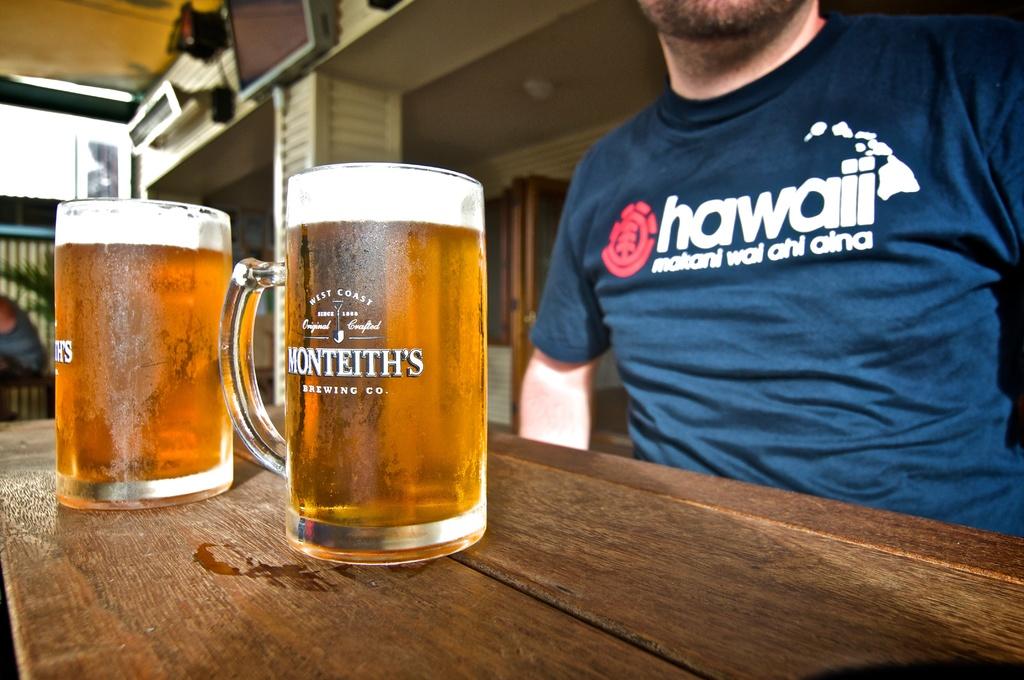What state does this man represent?
Keep it short and to the point. Hawaii. What is inscribed on the beer bottles?
Make the answer very short. Monteith's. 